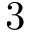Convert formula to latex. <formula><loc_0><loc_0><loc_500><loc_500>3</formula> 